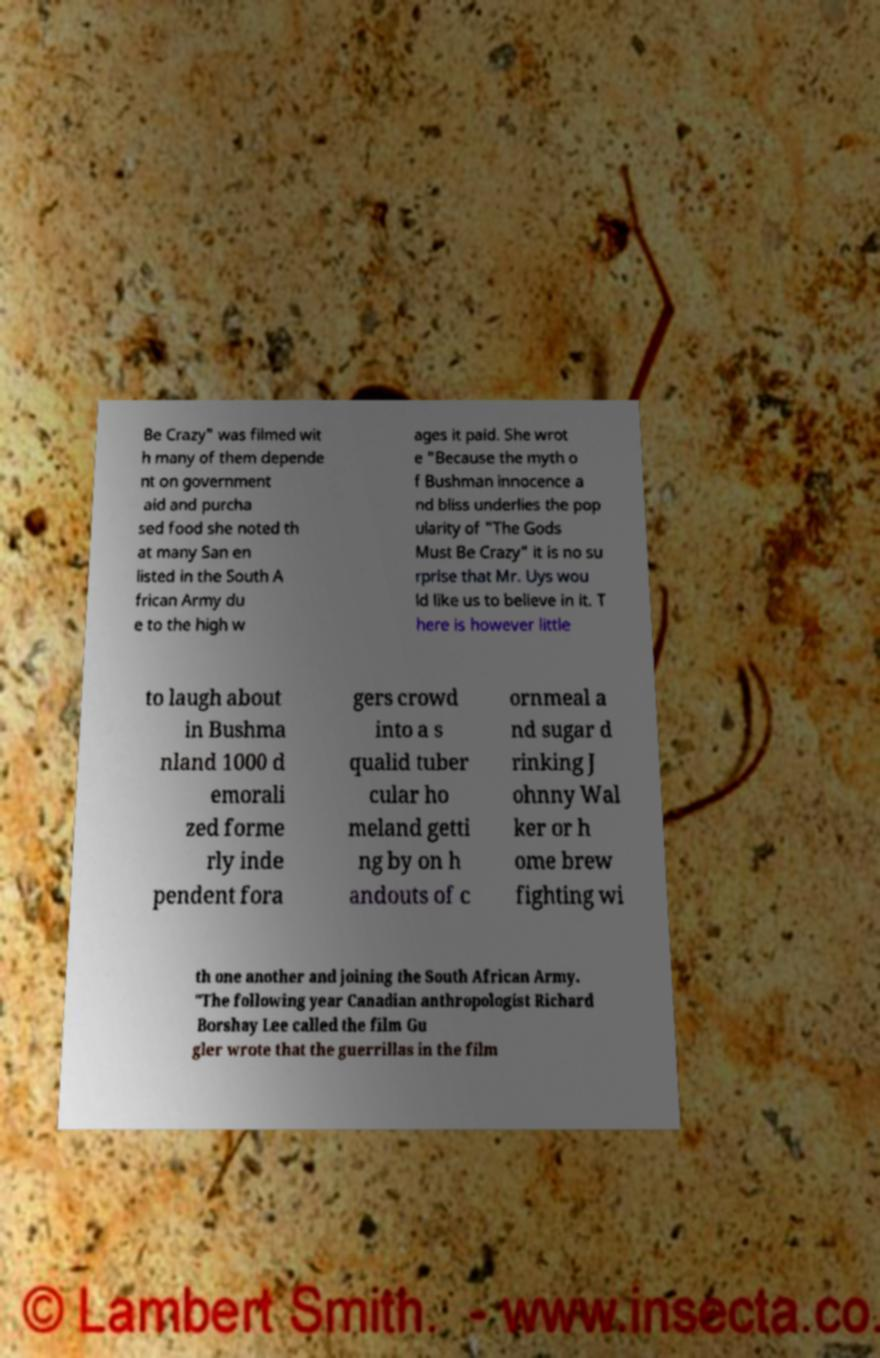Could you assist in decoding the text presented in this image and type it out clearly? Be Crazy" was filmed wit h many of them depende nt on government aid and purcha sed food she noted th at many San en listed in the South A frican Army du e to the high w ages it paid. She wrot e "Because the myth o f Bushman innocence a nd bliss underlies the pop ularity of "The Gods Must Be Crazy" it is no su rprise that Mr. Uys wou ld like us to believe in it. T here is however little to laugh about in Bushma nland 1000 d emorali zed forme rly inde pendent fora gers crowd into a s qualid tuber cular ho meland getti ng by on h andouts of c ornmeal a nd sugar d rinking J ohnny Wal ker or h ome brew fighting wi th one another and joining the South African Army. "The following year Canadian anthropologist Richard Borshay Lee called the film Gu gler wrote that the guerrillas in the film 